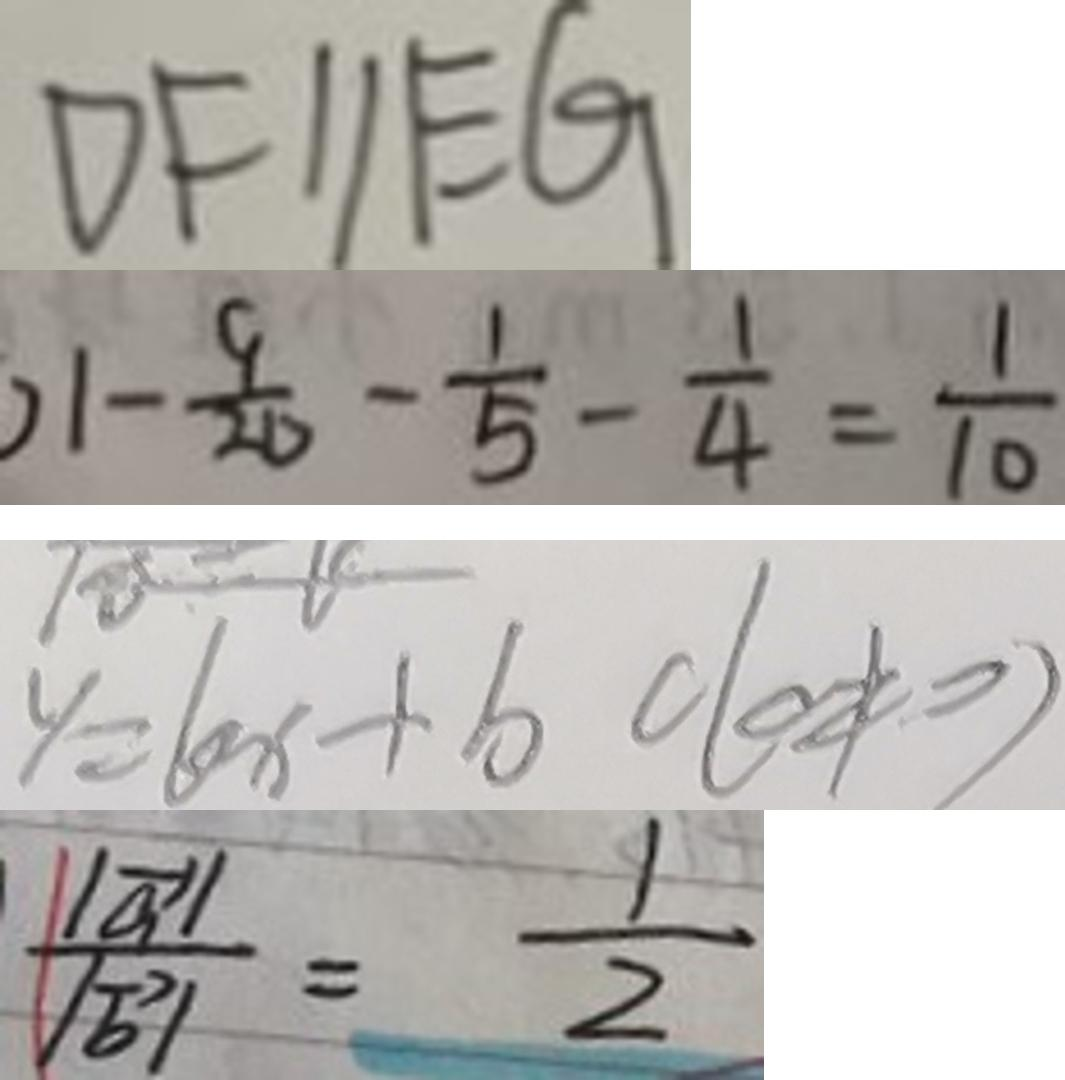Convert formula to latex. <formula><loc_0><loc_0><loc_500><loc_500>D F / / E G 
 1 - \frac { 9 } { 2 0 } - \frac { 1 } { 5 } - \frac { 1 } { 4 } = \frac { 1 } { 1 0 } 
 y = k x + b c ( c \neq 0 ) 
 \frac { \vert \overrightarrow { a } \vert } { \vert \overrightarrow { b } \vert } = \frac { 1 } { 2 }</formula> 